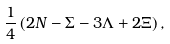Convert formula to latex. <formula><loc_0><loc_0><loc_500><loc_500>\frac { 1 } { 4 } \left ( 2 N - \Sigma - 3 \Lambda + 2 \Xi \right ) ,</formula> 